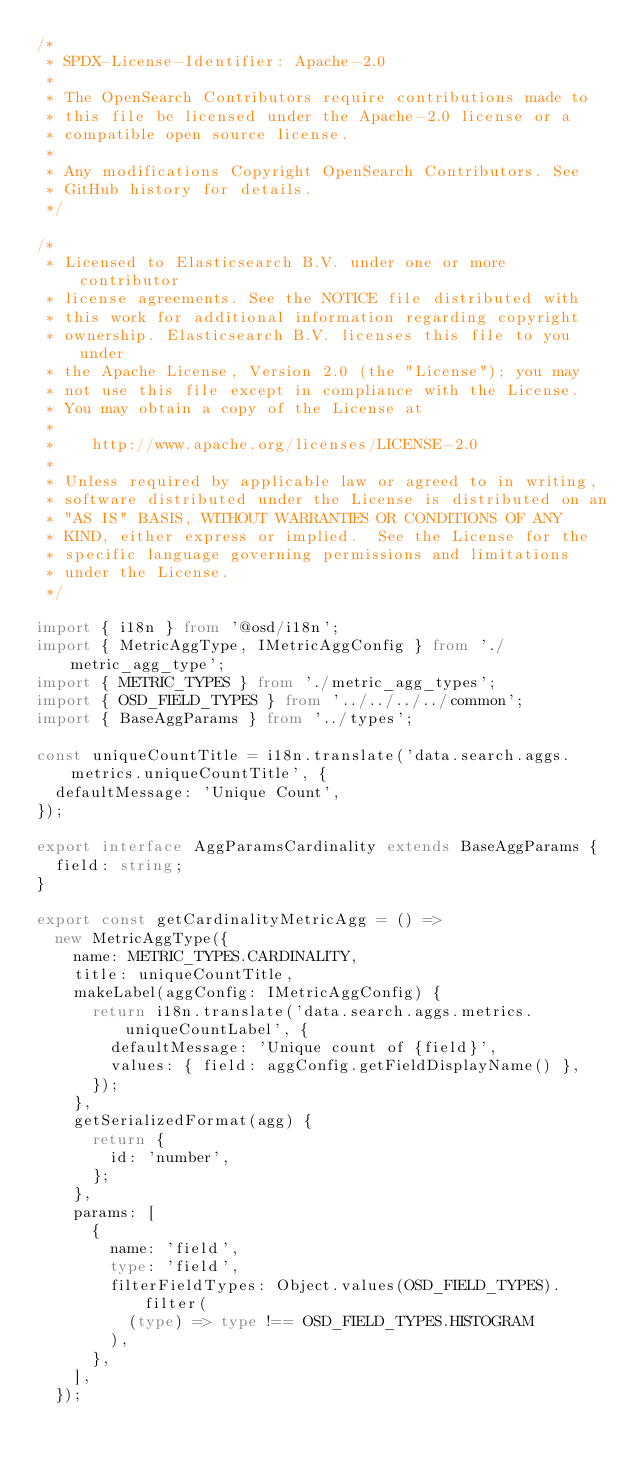Convert code to text. <code><loc_0><loc_0><loc_500><loc_500><_TypeScript_>/*
 * SPDX-License-Identifier: Apache-2.0
 *
 * The OpenSearch Contributors require contributions made to
 * this file be licensed under the Apache-2.0 license or a
 * compatible open source license.
 *
 * Any modifications Copyright OpenSearch Contributors. See
 * GitHub history for details.
 */

/*
 * Licensed to Elasticsearch B.V. under one or more contributor
 * license agreements. See the NOTICE file distributed with
 * this work for additional information regarding copyright
 * ownership. Elasticsearch B.V. licenses this file to you under
 * the Apache License, Version 2.0 (the "License"); you may
 * not use this file except in compliance with the License.
 * You may obtain a copy of the License at
 *
 *    http://www.apache.org/licenses/LICENSE-2.0
 *
 * Unless required by applicable law or agreed to in writing,
 * software distributed under the License is distributed on an
 * "AS IS" BASIS, WITHOUT WARRANTIES OR CONDITIONS OF ANY
 * KIND, either express or implied.  See the License for the
 * specific language governing permissions and limitations
 * under the License.
 */

import { i18n } from '@osd/i18n';
import { MetricAggType, IMetricAggConfig } from './metric_agg_type';
import { METRIC_TYPES } from './metric_agg_types';
import { OSD_FIELD_TYPES } from '../../../../common';
import { BaseAggParams } from '../types';

const uniqueCountTitle = i18n.translate('data.search.aggs.metrics.uniqueCountTitle', {
  defaultMessage: 'Unique Count',
});

export interface AggParamsCardinality extends BaseAggParams {
  field: string;
}

export const getCardinalityMetricAgg = () =>
  new MetricAggType({
    name: METRIC_TYPES.CARDINALITY,
    title: uniqueCountTitle,
    makeLabel(aggConfig: IMetricAggConfig) {
      return i18n.translate('data.search.aggs.metrics.uniqueCountLabel', {
        defaultMessage: 'Unique count of {field}',
        values: { field: aggConfig.getFieldDisplayName() },
      });
    },
    getSerializedFormat(agg) {
      return {
        id: 'number',
      };
    },
    params: [
      {
        name: 'field',
        type: 'field',
        filterFieldTypes: Object.values(OSD_FIELD_TYPES).filter(
          (type) => type !== OSD_FIELD_TYPES.HISTOGRAM
        ),
      },
    ],
  });
</code> 